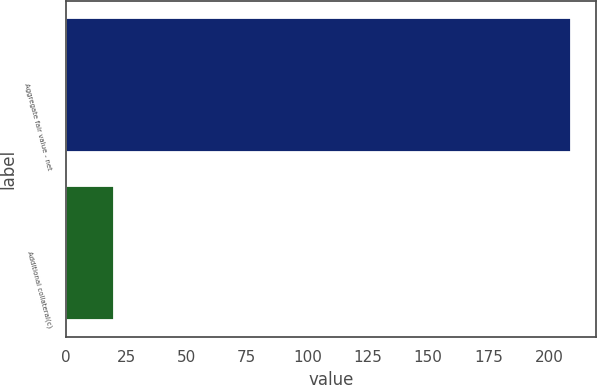Convert chart to OTSL. <chart><loc_0><loc_0><loc_500><loc_500><bar_chart><fcel>Aggregate fair value - net<fcel>Additional collateral(c)<nl><fcel>209<fcel>20<nl></chart> 